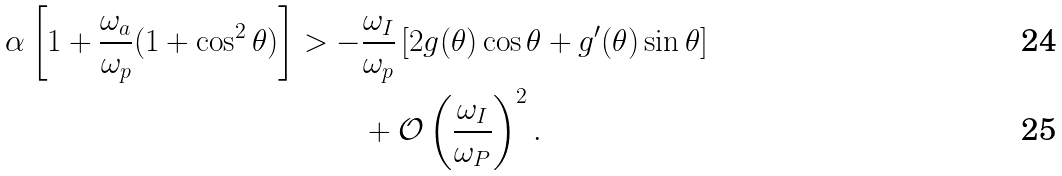Convert formula to latex. <formula><loc_0><loc_0><loc_500><loc_500>\alpha \left [ 1 + \frac { \omega _ { a } } { \omega _ { p } } ( 1 + \cos ^ { 2 } \theta ) \right ] > - & \frac { \omega _ { I } } { \omega _ { p } } \left [ 2 g ( \theta ) \cos \theta + g ^ { \prime } ( \theta ) \sin \theta \right ] \\ & + \mathcal { O } \left ( \frac { \omega _ { I } } { \omega _ { P } } \right ) ^ { 2 } .</formula> 